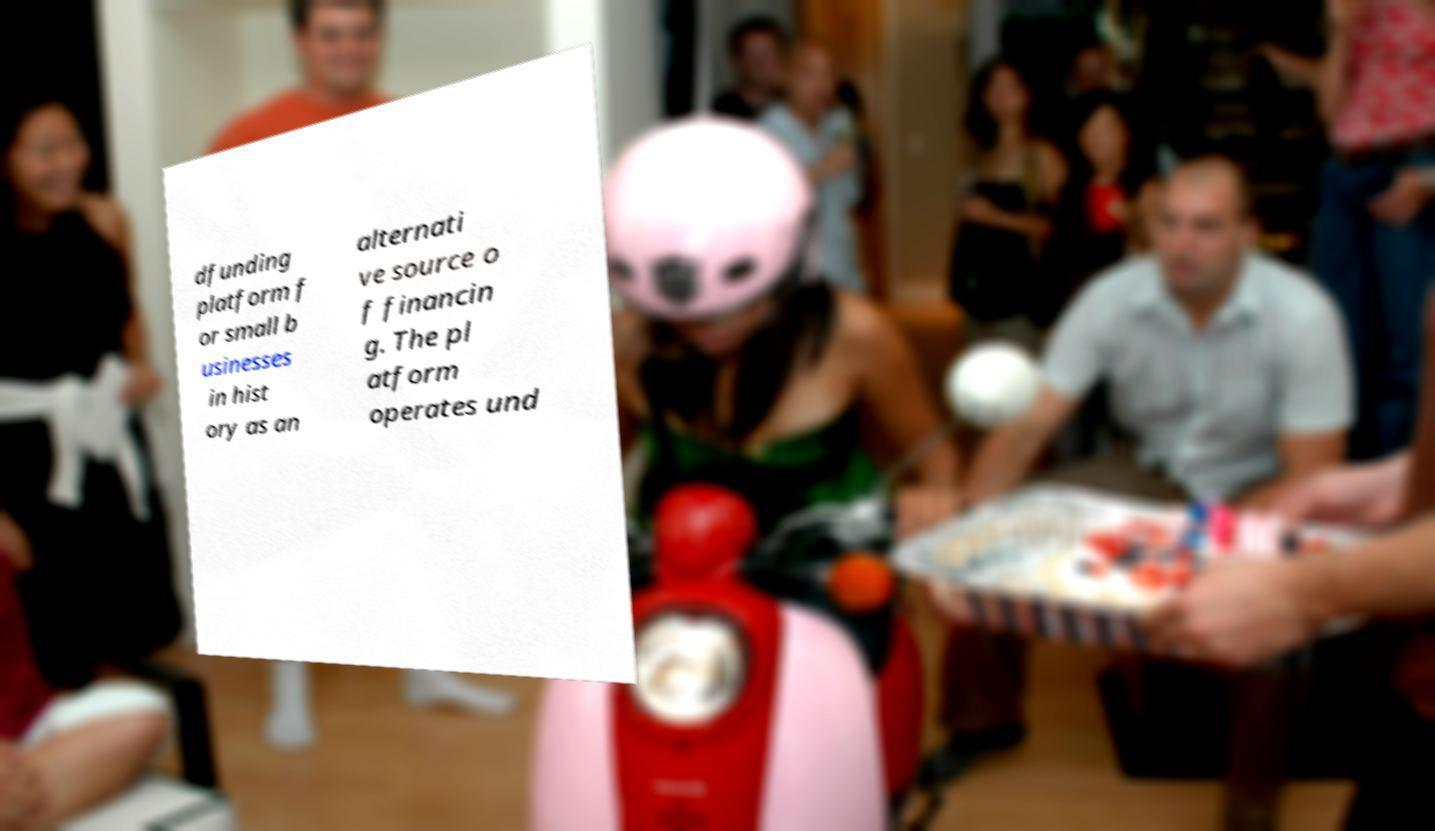For documentation purposes, I need the text within this image transcribed. Could you provide that? dfunding platform f or small b usinesses in hist ory as an alternati ve source o f financin g. The pl atform operates und 